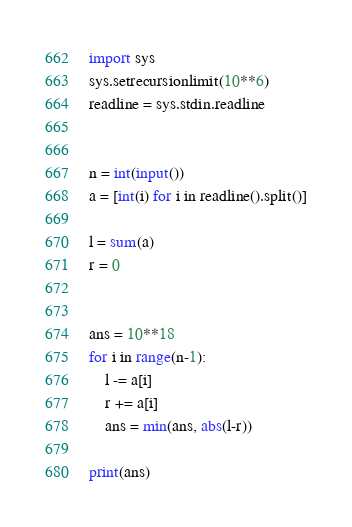<code> <loc_0><loc_0><loc_500><loc_500><_Python_>
import sys
sys.setrecursionlimit(10**6)
readline = sys.stdin.readline 


n = int(input())
a = [int(i) for i in readline().split()]

l = sum(a)
r = 0


ans = 10**18
for i in range(n-1):
    l -= a[i]
    r += a[i]
    ans = min(ans, abs(l-r))

print(ans)    
</code> 